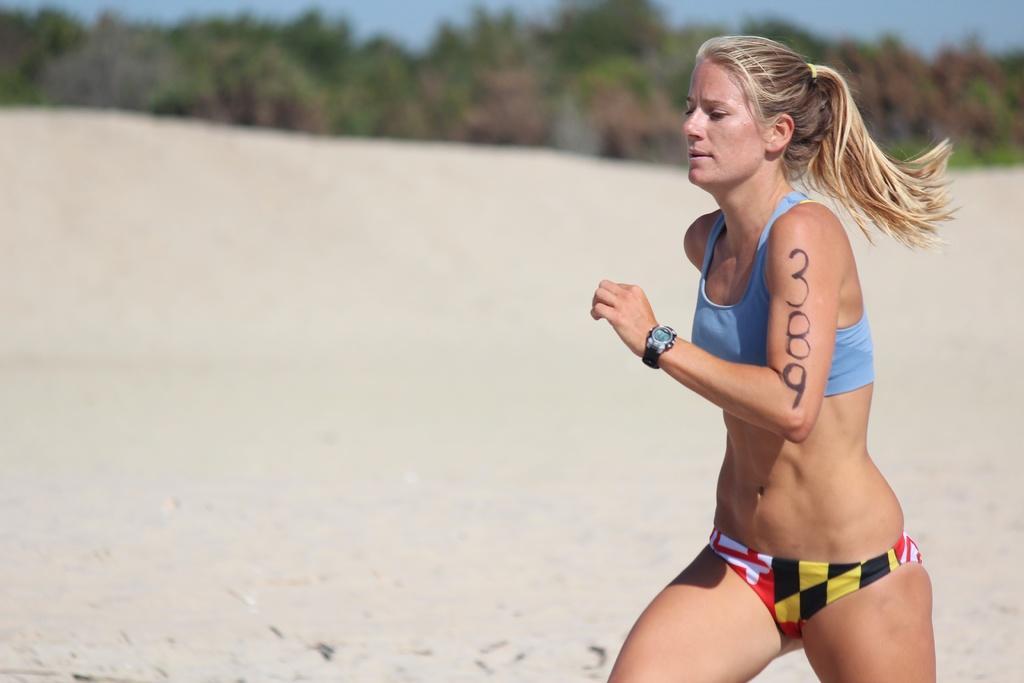Could you give a brief overview of what you see in this image? This picture is clicked outside. On the right we can see a woman running on the ground. In the background we can see the sky, trees and some other objects. 